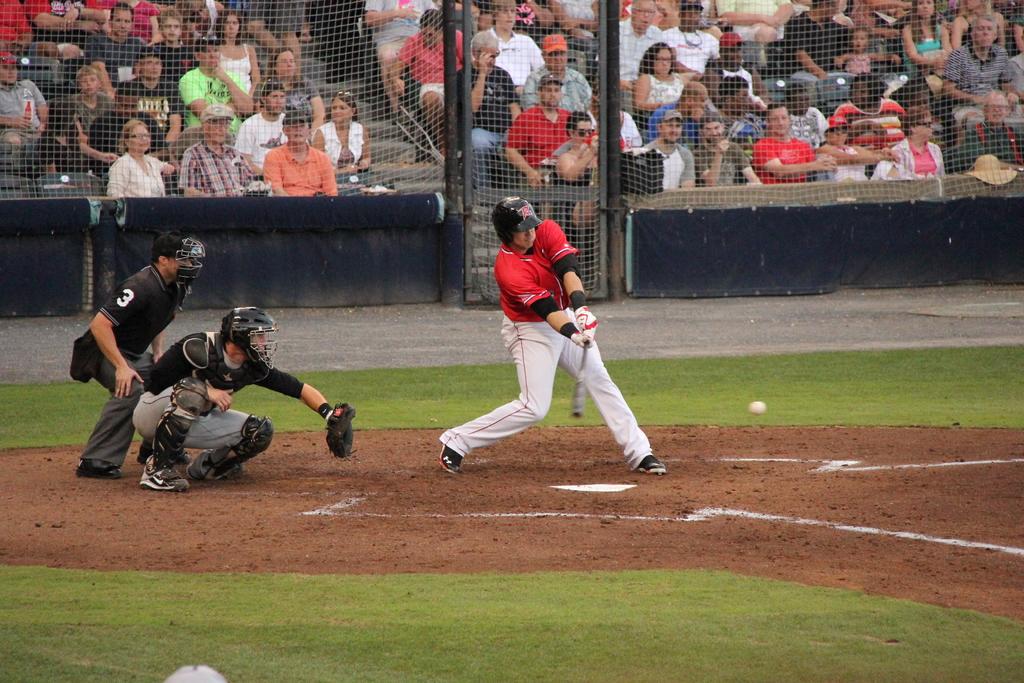What is the umpire's number?
Give a very brief answer. 3. 